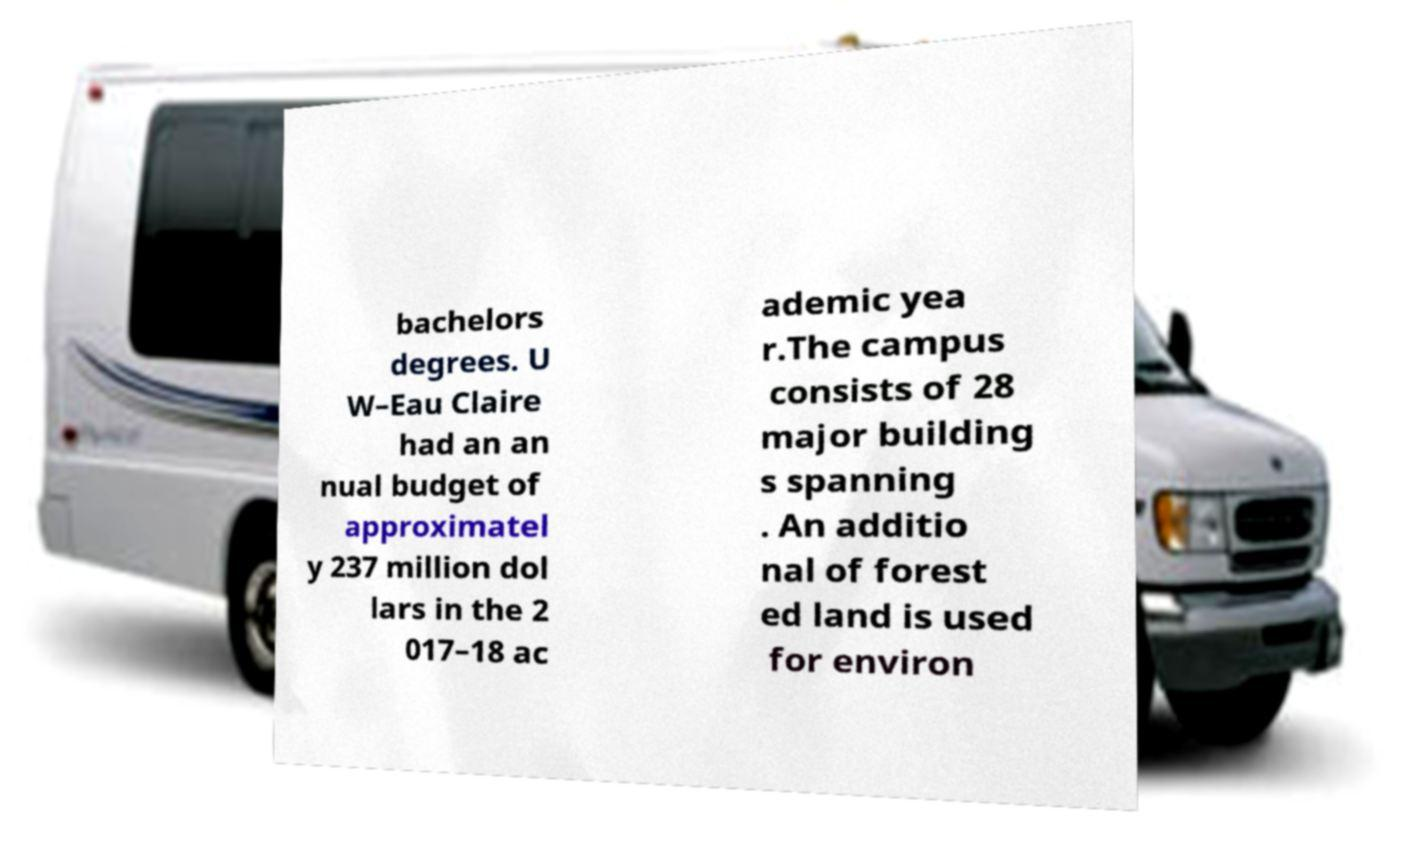Could you extract and type out the text from this image? bachelors degrees. U W–Eau Claire had an an nual budget of approximatel y 237 million dol lars in the 2 017–18 ac ademic yea r.The campus consists of 28 major building s spanning . An additio nal of forest ed land is used for environ 